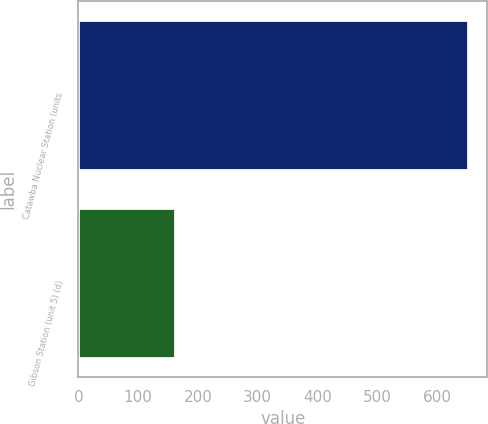Convert chart to OTSL. <chart><loc_0><loc_0><loc_500><loc_500><bar_chart><fcel>Catawba Nuclear Station (units<fcel>Gibson Station (unit 5) (d)<nl><fcel>651<fcel>162<nl></chart> 